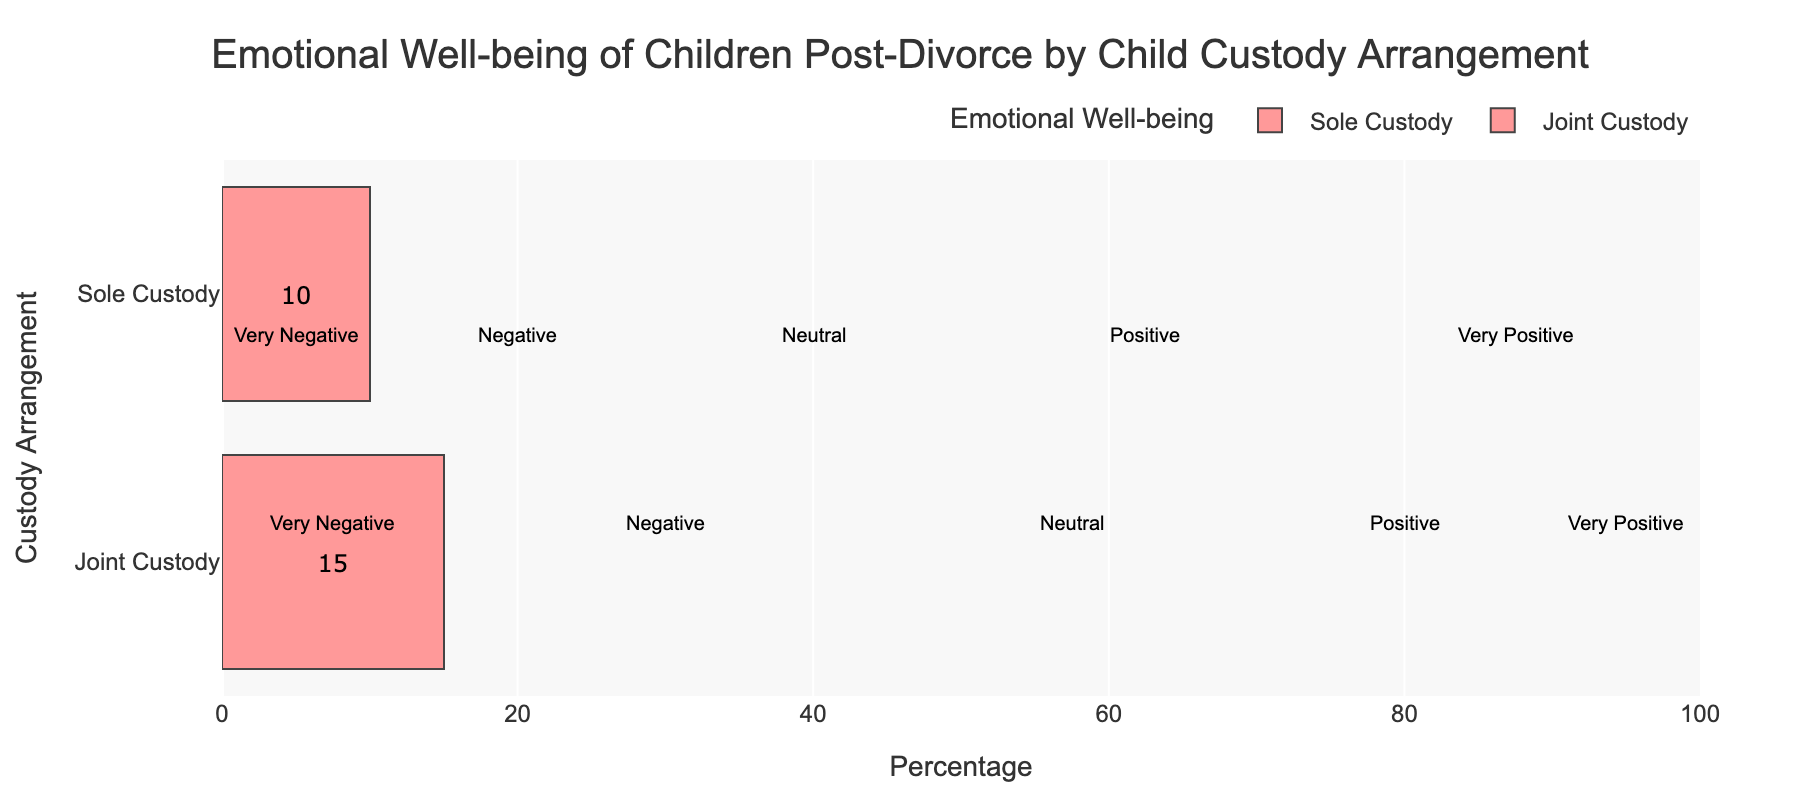What's the percentage of children in the Very Positive emotional well-being category for Joint Custody? Look for the bar titled "Joint Custody" and find the section labeled "Very Positive." The label inside the bar shows the percentage.
Answer: 15% Which custody arrangement has a higher percentage of children in the Negative category? Compare the percentages of the Negative category for both Joint Custody and Sole Custody. Joint Custody has a value of 20%, while Sole Custody has 25%.
Answer: Sole Custody What is the total percentage of children with Positive or Very Positive emotional well-being in Sole Custody? Sum the percentages of the Positive and Very Positive categories for Sole Custody. The values are 20% and 10%, respectively. Therefore, 20% + 10% = 30%.
Answer: 30% Compare the percentage of children with Neutral emotional well-being between Joint Custody and Sole Custody. Which is higher? Look at the bars for the Neutral category. Joint Custody has 25% and Sole Custody has 20%. Therefore, Joint Custody has a higher percentage.
Answer: Joint Custody What is the combined percentage of children experiencing Negative and Very Negative emotional well-being in Joint Custody? Sum the percentages for Negative and Very Negative categories in Joint Custody. The values are 20% and 10%, respectively. Therefore, 20% + 10% = 30%.
Answer: 30% Does Joint Custody or Sole Custody have more children with Very Negative emotional well-being? Compare the percentages in the Very Negative category between Joint Custody and Sole Custody. Joint Custody has 10%, and Sole Custody has 25%.
Answer: Sole Custody What is the difference in the percentage of Neutral emotional well-being children between Joint Custody and Sole Custody? Subtract the Neutral percentage for Sole Custody from that of Joint Custody. Joint Custody has 25%, and Sole Custody has 20%. Therefore, 25% - 20% = 5%.
Answer: 5% Which custody arrangement has a higher proportion of positive emotional well-being (Positive + Very Positive)? Calculate the sum of Positive and Very Positive categories for both arrangements and compare them. Joint Custody has 15% (Very Positive) + 30% (Positive) = 45%. Sole Custody has 10% (Very Positive) + 20% (Positive) = 30%. Joint Custody has a higher proportion.
Answer: Joint Custody 